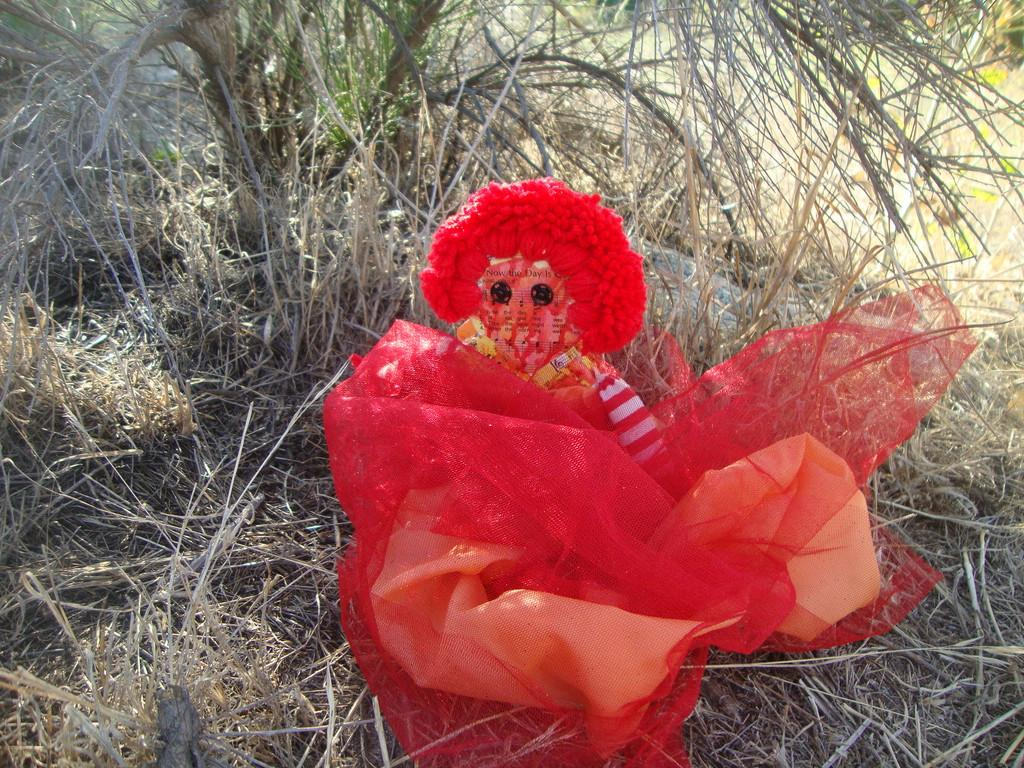What is the color of the toy in the image? The toy in the image is red. What type of natural material can be seen in the image? There is dried grass in the image. What is the name of the daughter in the image? There is no daughter present in the image. Is there a boat visible in the image? There is no boat present in the image. 